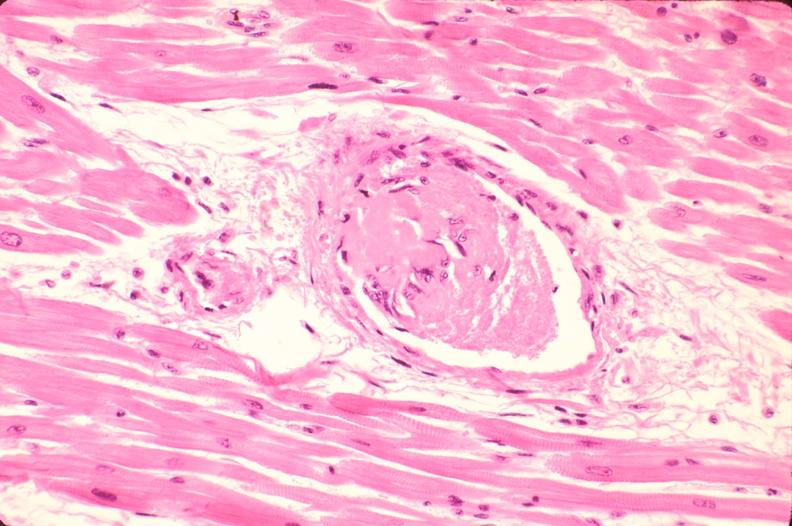does this image shows of smooth muscle cell with lipid in sarcoplasm and lipid show heart, microthrombi, thrombotic thrombocytopenic purpura?
Answer the question using a single word or phrase. No 